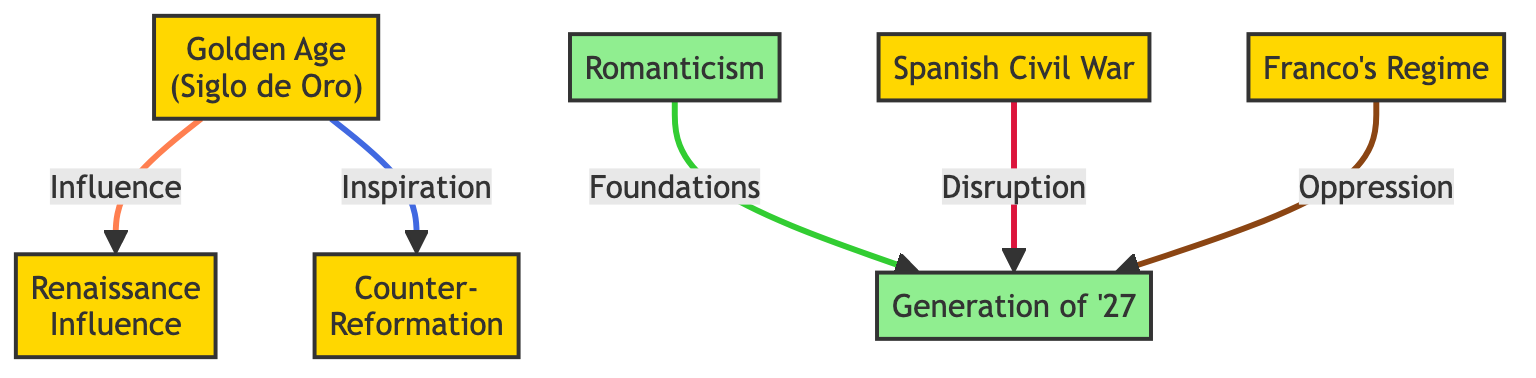What historical event influenced the Renaissance in Spanish poetry? In the diagram, an arrow indicates that the Golden Age has an influence on the Renaissance. Therefore, the historical event that influenced the Renaissance is the Golden Age.
Answer: Golden Age How many literary movements are represented in the diagram? The diagram includes two literary movements: Romanticism and the Generation of '27. By counting the distinct literary nodes, we get a total of two.
Answer: 2 Which historical event has connections with the Generation of '27? The diagram shows that both Romanticism and the Civil War connect to the Generation of '27. Thus, the historical events related to it are Romanticism and the Civil War.
Answer: Romanticism, Civil War What type of influence did the Golden Age have on the Counter-Reformation? The diagram specifies that the connection from the Golden Age to the Counter-Reformation is labeled as "Inspiration." Thus, the influence is inspirational.
Answer: Inspiration What is the relationship between the Franco Regime and the Generation of '27? According to the diagram, the Franco Regime is connected to the Generation of '27 with an arrow indicating "Oppression," meaning the relationship is characterized by oppression.
Answer: Oppression 